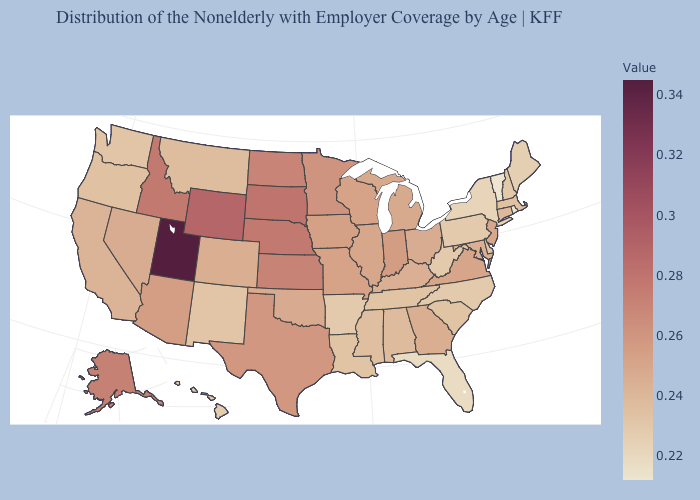Among the states that border Indiana , which have the highest value?
Answer briefly. Illinois. Is the legend a continuous bar?
Concise answer only. Yes. Does Maine have the lowest value in the USA?
Answer briefly. No. Does the map have missing data?
Be succinct. No. 